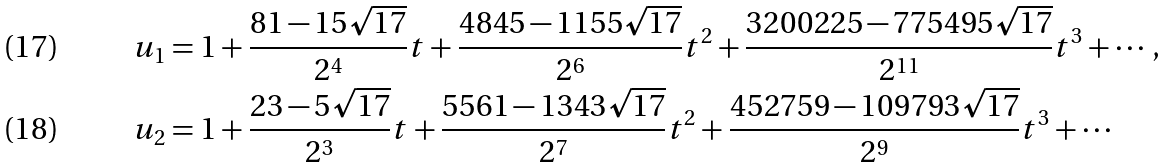<formula> <loc_0><loc_0><loc_500><loc_500>u _ { 1 } & = 1 + \frac { 8 1 - 1 5 \sqrt { 1 7 } } { 2 ^ { 4 } } t + \frac { 4 8 4 5 - 1 1 5 5 \sqrt { 1 7 } } { 2 ^ { 6 } } t ^ { 2 } + \frac { 3 2 0 0 2 2 5 - 7 7 5 4 9 5 \sqrt { 1 7 } } { 2 ^ { 1 1 } } t ^ { 3 } + \cdots , \\ u _ { 2 } & = 1 + \frac { 2 3 - 5 \sqrt { 1 7 } } { 2 ^ { 3 } } t + \frac { 5 5 6 1 - 1 3 4 3 \sqrt { 1 7 } } { 2 ^ { 7 } } t ^ { 2 } + \frac { 4 5 2 7 5 9 - 1 0 9 7 9 3 \sqrt { 1 7 } } { 2 ^ { 9 } } t ^ { 3 } + \cdots</formula> 